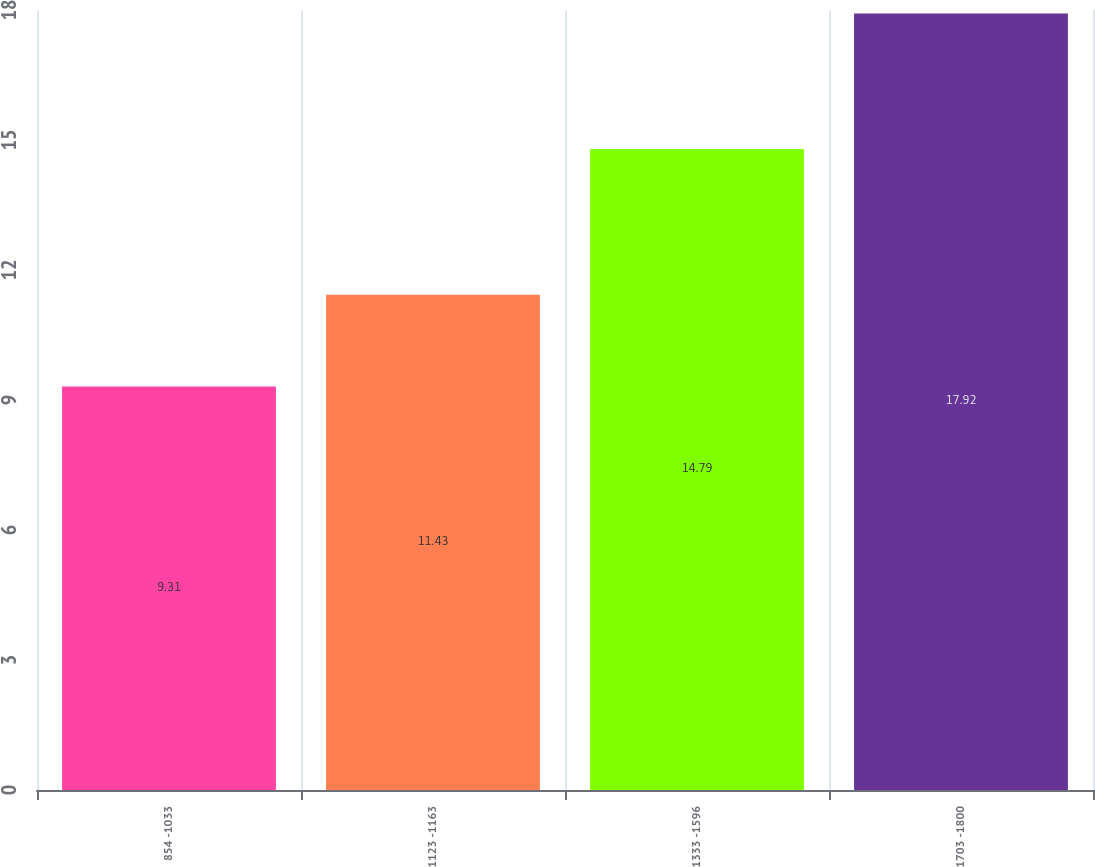<chart> <loc_0><loc_0><loc_500><loc_500><bar_chart><fcel>854 -1033<fcel>1123 -1163<fcel>1333 -1596<fcel>1703 -1800<nl><fcel>9.31<fcel>11.43<fcel>14.79<fcel>17.92<nl></chart> 